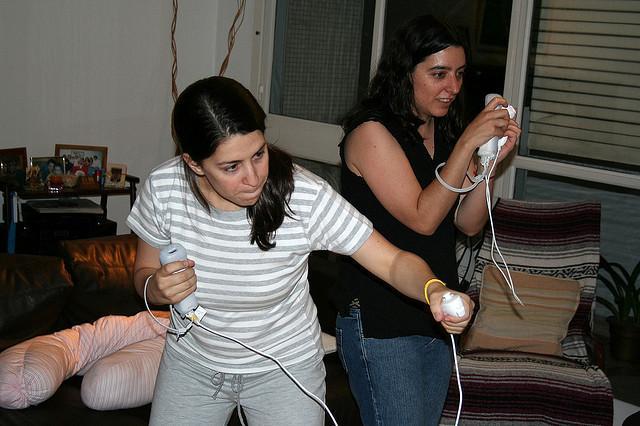How many people are there?
Give a very brief answer. 2. 